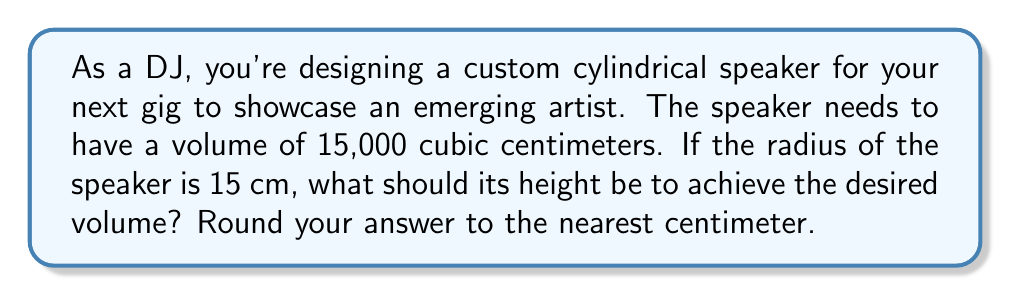Solve this math problem. To solve this problem, we need to use the formula for the volume of a cylinder and then solve for the height. Let's break it down step-by-step:

1. The formula for the volume of a cylinder is:
   $$V = \pi r^2 h$$
   where $V$ is the volume, $r$ is the radius, and $h$ is the height.

2. We know the following:
   - Volume (V) = 15,000 cm³
   - Radius (r) = 15 cm
   - Height (h) is unknown

3. Let's substitute the known values into the formula:
   $$15,000 = \pi (15)^2 h$$

4. Simplify the right side of the equation:
   $$15,000 = \pi (225) h$$
   $$15,000 = 706.86 h$$

5. Now, solve for h by dividing both sides by 706.86:
   $$h = \frac{15,000}{706.86}$$

6. Calculate the result:
   $$h \approx 21.22 \text{ cm}$$

7. Rounding to the nearest centimeter:
   $$h \approx 21 \text{ cm}$$

Therefore, the height of the cylindrical speaker should be approximately 21 cm to achieve a volume of 15,000 cubic centimeters with a radius of 15 cm.
Answer: 21 cm 